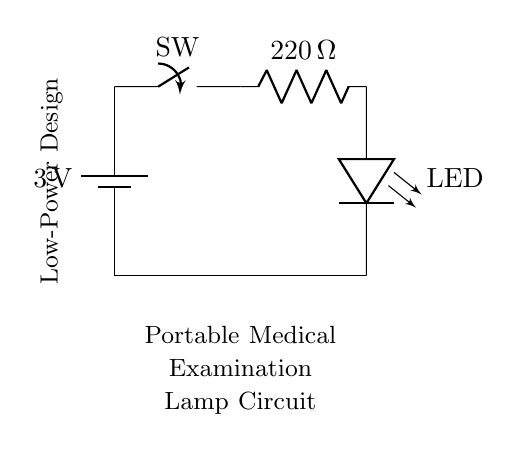What is the voltage of this circuit? The voltage is 3 volts, indicated on the battery symbol at the top left of the circuit diagram.
Answer: 3 volts What type of circuit is this? This is a series circuit because all components are connected in a single path, so the same current flows through each component.
Answer: Series circuit What is the function of the resistor in this circuit? The resistor limits current to the LED to prevent it from drawing too much current and likely burning out. Its value is set to 220 ohms, ensuring the LED operates safely.
Answer: Current limiting How many main components are in the circuit? There are four main components: a battery, a switch, a resistor, and an LED. Counting each of these elements gives a total of four distinct components.
Answer: Four What is the purpose of the switch in this circuit? The switch's purpose is to control the flow of electricity in the circuit, allowing the user to turn the LED on or off as needed.
Answer: To control electricity What is the current limiting resistor value? The current limiting resistor is set to 220 ohms, as labeled next to the resistor in the circuit diagram. This value helps to regulate the current flowing through the LED.
Answer: 220 ohms What type of light source is used in this circuit? The circuit uses an LED (Light Emitting Diode) as the light source, specified by the LED symbol in the diagram.
Answer: LED 